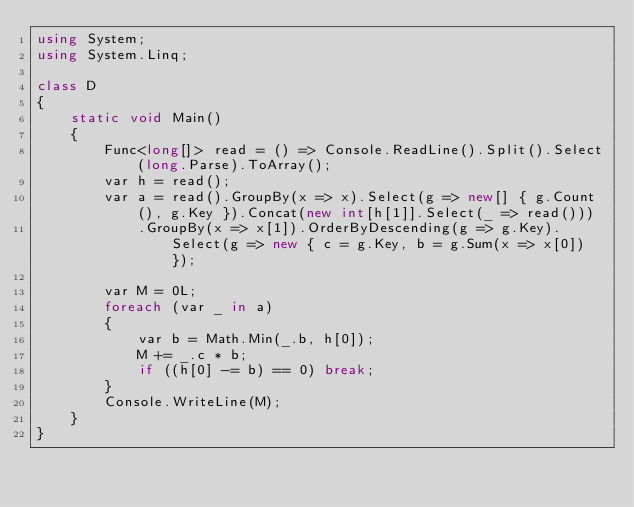<code> <loc_0><loc_0><loc_500><loc_500><_C#_>using System;
using System.Linq;

class D
{
	static void Main()
	{
		Func<long[]> read = () => Console.ReadLine().Split().Select(long.Parse).ToArray();
		var h = read();
		var a = read().GroupBy(x => x).Select(g => new[] { g.Count(), g.Key }).Concat(new int[h[1]].Select(_ => read()))
			.GroupBy(x => x[1]).OrderByDescending(g => g.Key).Select(g => new { c = g.Key, b = g.Sum(x => x[0]) });

		var M = 0L;
		foreach (var _ in a)
		{
			var b = Math.Min(_.b, h[0]);
			M += _.c * b;
			if ((h[0] -= b) == 0) break;
		}
		Console.WriteLine(M);
	}
}
</code> 